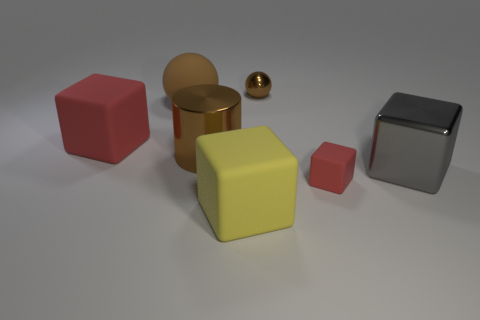Can you describe the arrangement of objects based on their relative sizes? Certainly! In the image, the objects are arranged with a mix of larger and smaller sizes. There is a large red cube, a large metal cylinder, and a large metallic block, paired with smaller versions of a cube and cylinder, as well as a small spherical object. 